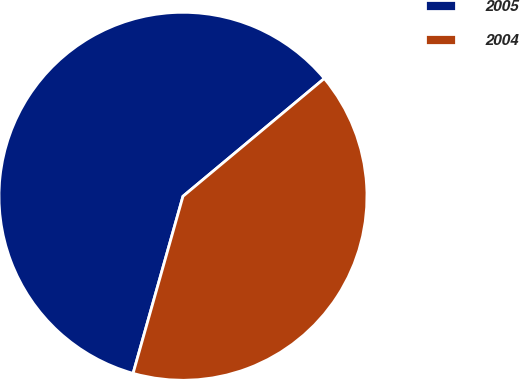Convert chart to OTSL. <chart><loc_0><loc_0><loc_500><loc_500><pie_chart><fcel>2005<fcel>2004<nl><fcel>59.57%<fcel>40.43%<nl></chart> 